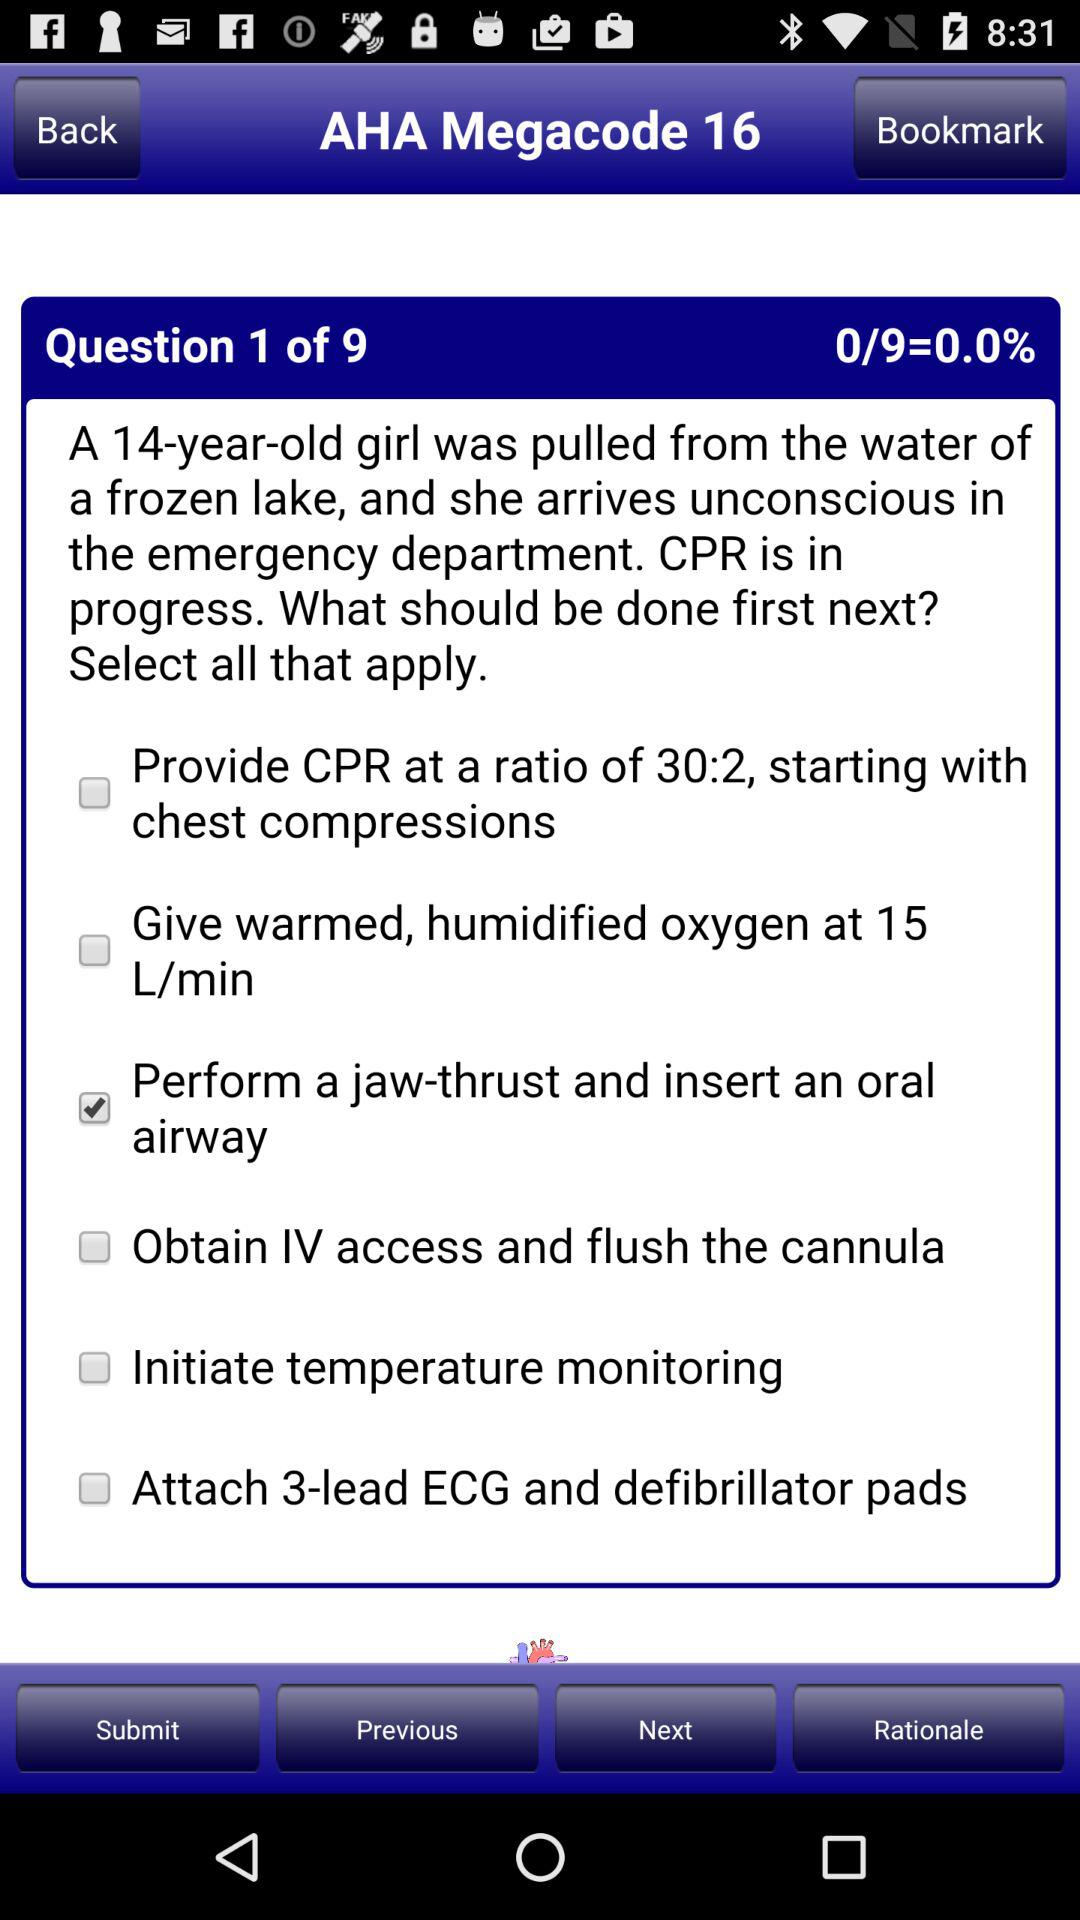At which question am I? You are at the first question. 